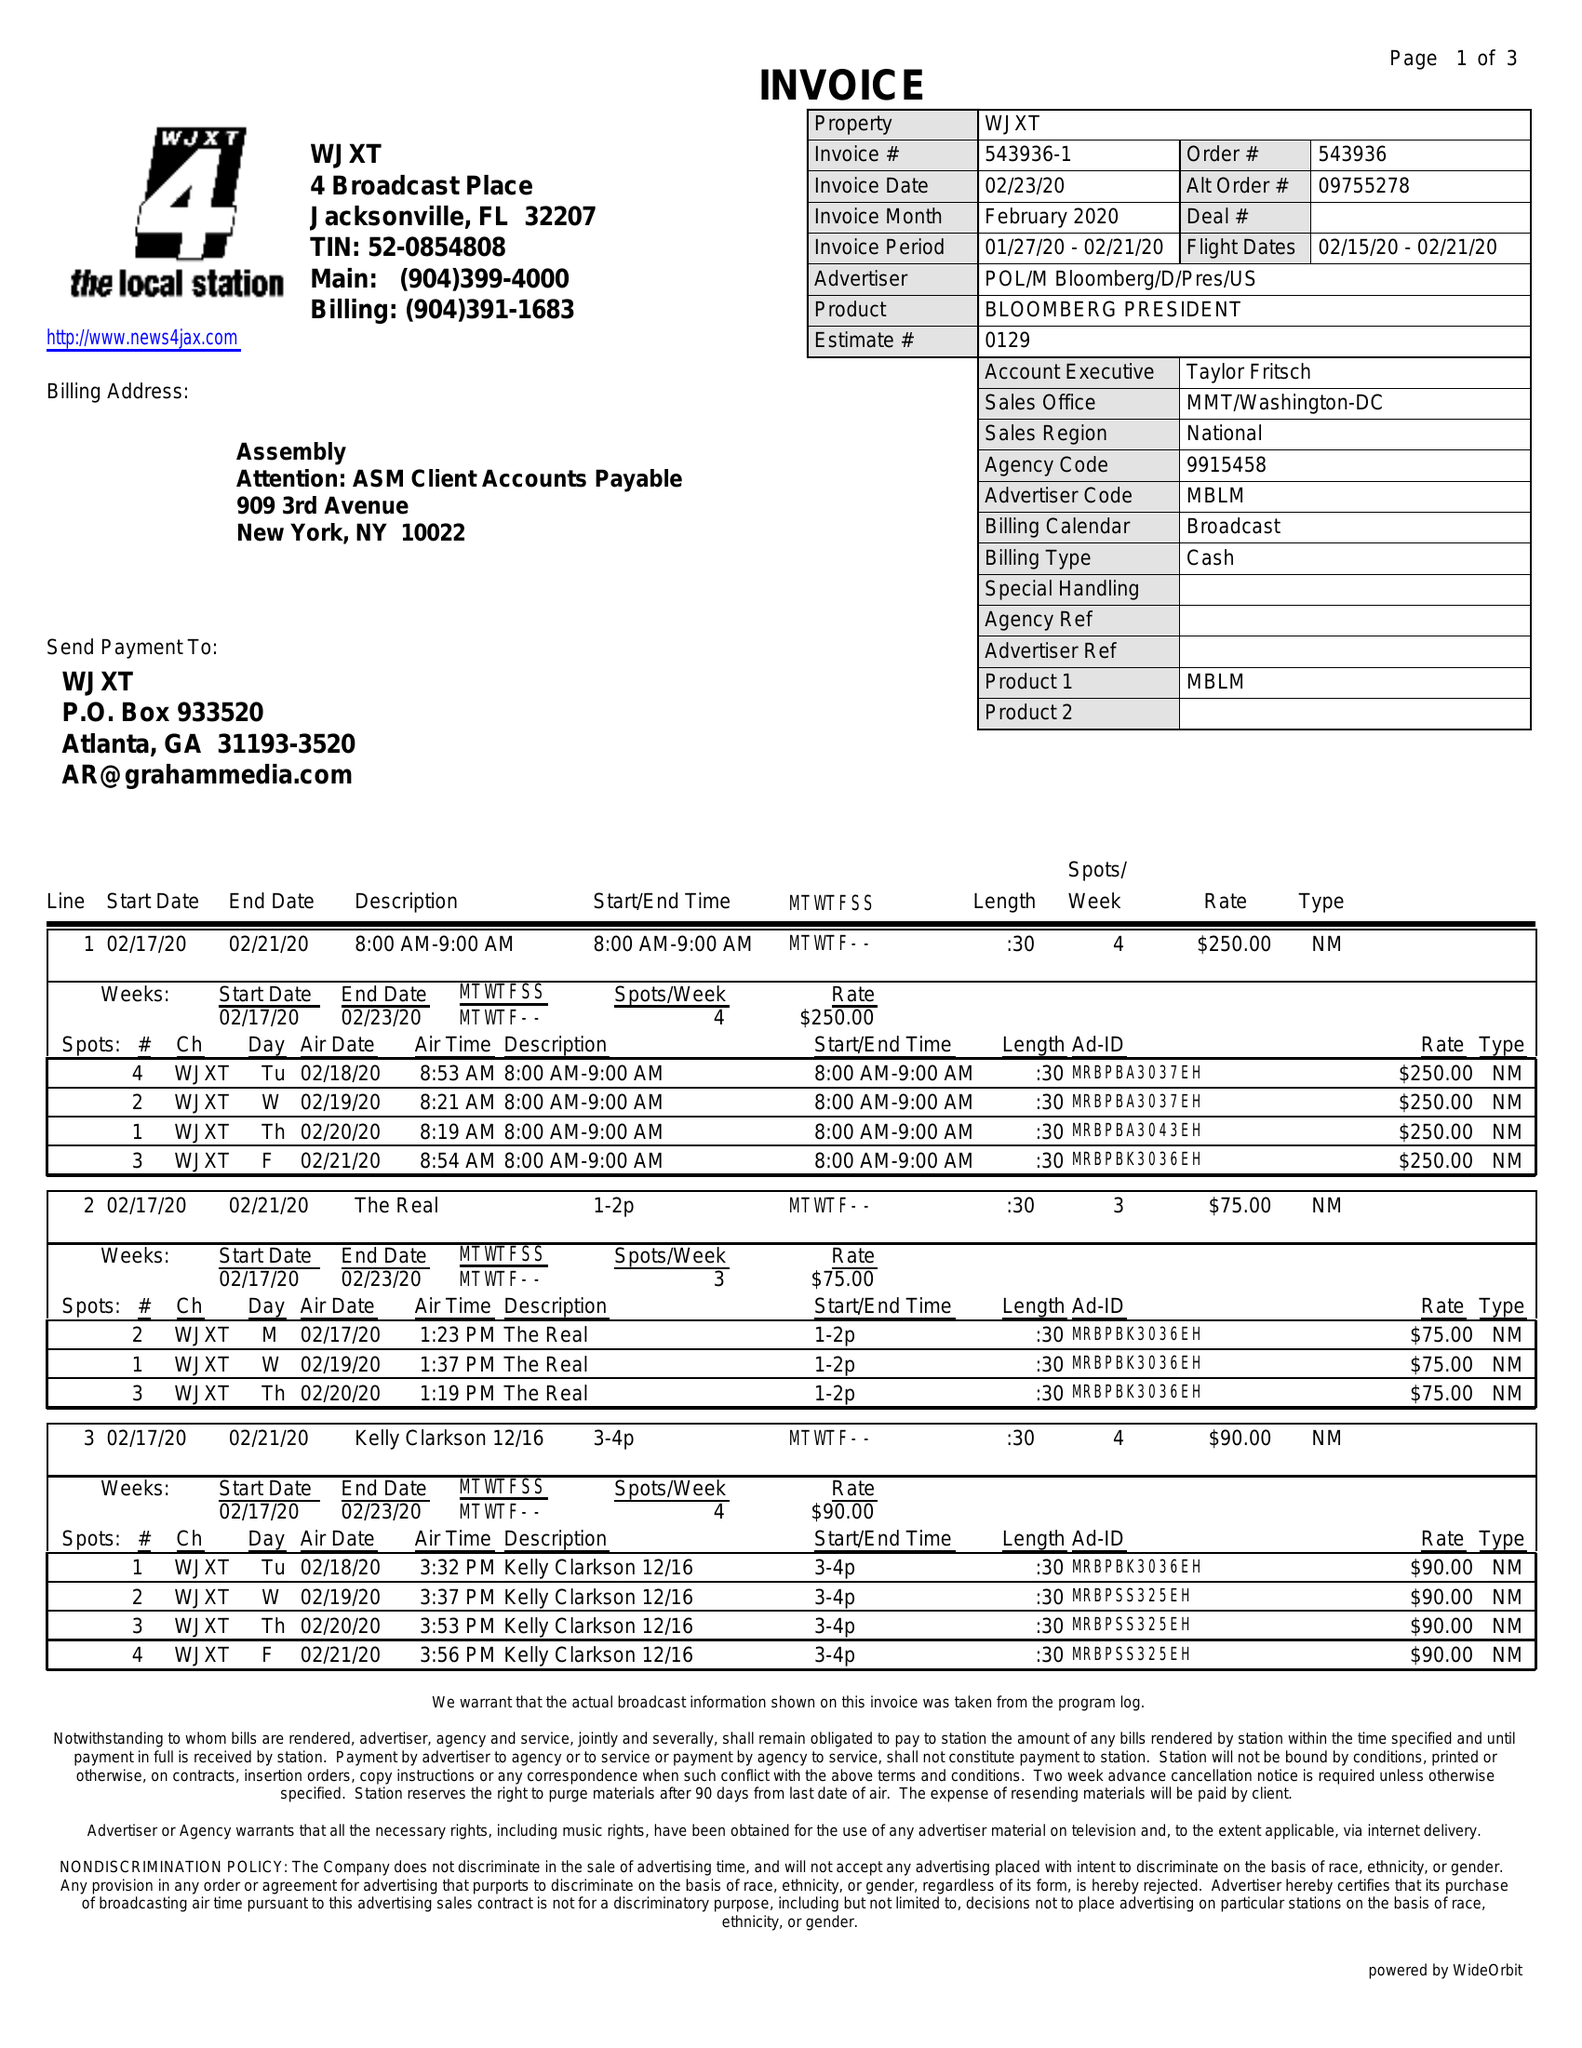What is the value for the contract_num?
Answer the question using a single word or phrase. 543936 